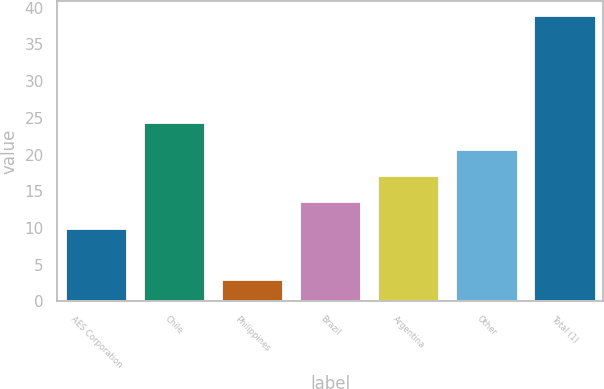Convert chart. <chart><loc_0><loc_0><loc_500><loc_500><bar_chart><fcel>AES Corporation<fcel>Chile<fcel>Philippines<fcel>Brazil<fcel>Argentina<fcel>Other<fcel>Total (1)<nl><fcel>10<fcel>24.4<fcel>3<fcel>13.6<fcel>17.2<fcel>20.8<fcel>39<nl></chart> 